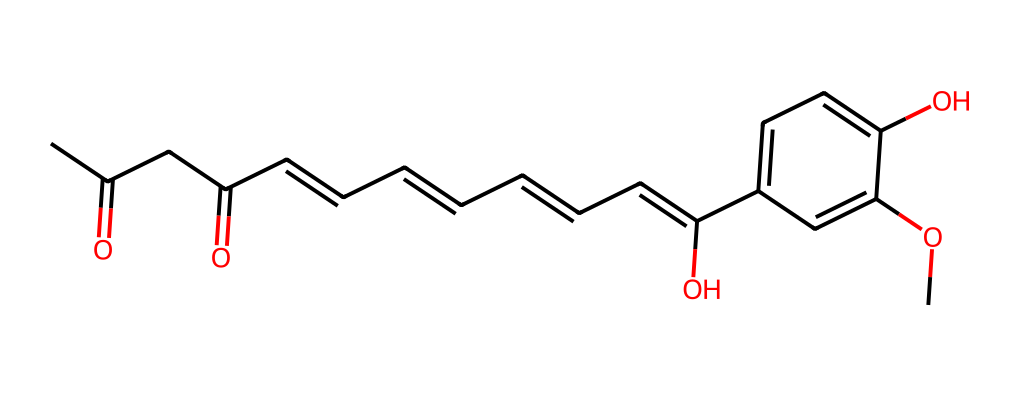What is the chemical name of this structure? The structure corresponds to curcumin, which is a well-known antioxidant derived from turmeric. The name can be derived from its chemical components and structure.
Answer: curcumin How many rings are present in the structure? The SMILES representation indicates the presence of one benzene ring, which is apparent from the cyclic notation. Counting the ring, we see only one.
Answer: one What type of functional groups are present in this molecule? The structure shows carbonyl (ketone) and hydroxyl (alcohol) functional groups, which can be recognized from the specific SMILES segments indicating their presence.
Answer: ketone, alcohol What is the total number of carbon atoms in this structure? By analyzing the SMILES notation, we count the number of carbon (C) atoms in the structural formula. There are 21 carbon atoms in total.
Answer: 21 Does this molecule contain any double bonds? The presence of '=' symbols in the SMILES indicates the existence of double bonds in the molecule. For this structure, there are multiple double bonds observed.
Answer: yes What role does the hydroxyl group play in the antioxidant capacity of curcumin? Hydroxyl groups are known for contributing to the antioxidant properties of compounds. They are effective in scavenging free radicals and reducing oxidative stress.
Answer: scavenging How many degrees of unsaturation does this molecule have? The degrees of unsaturation can be calculated by determining the number of rings and double bonds present in the structure. In this case, we see multiple unsaturated connections. After calculation, there are 8 degrees of unsaturation in total.
Answer: 8 